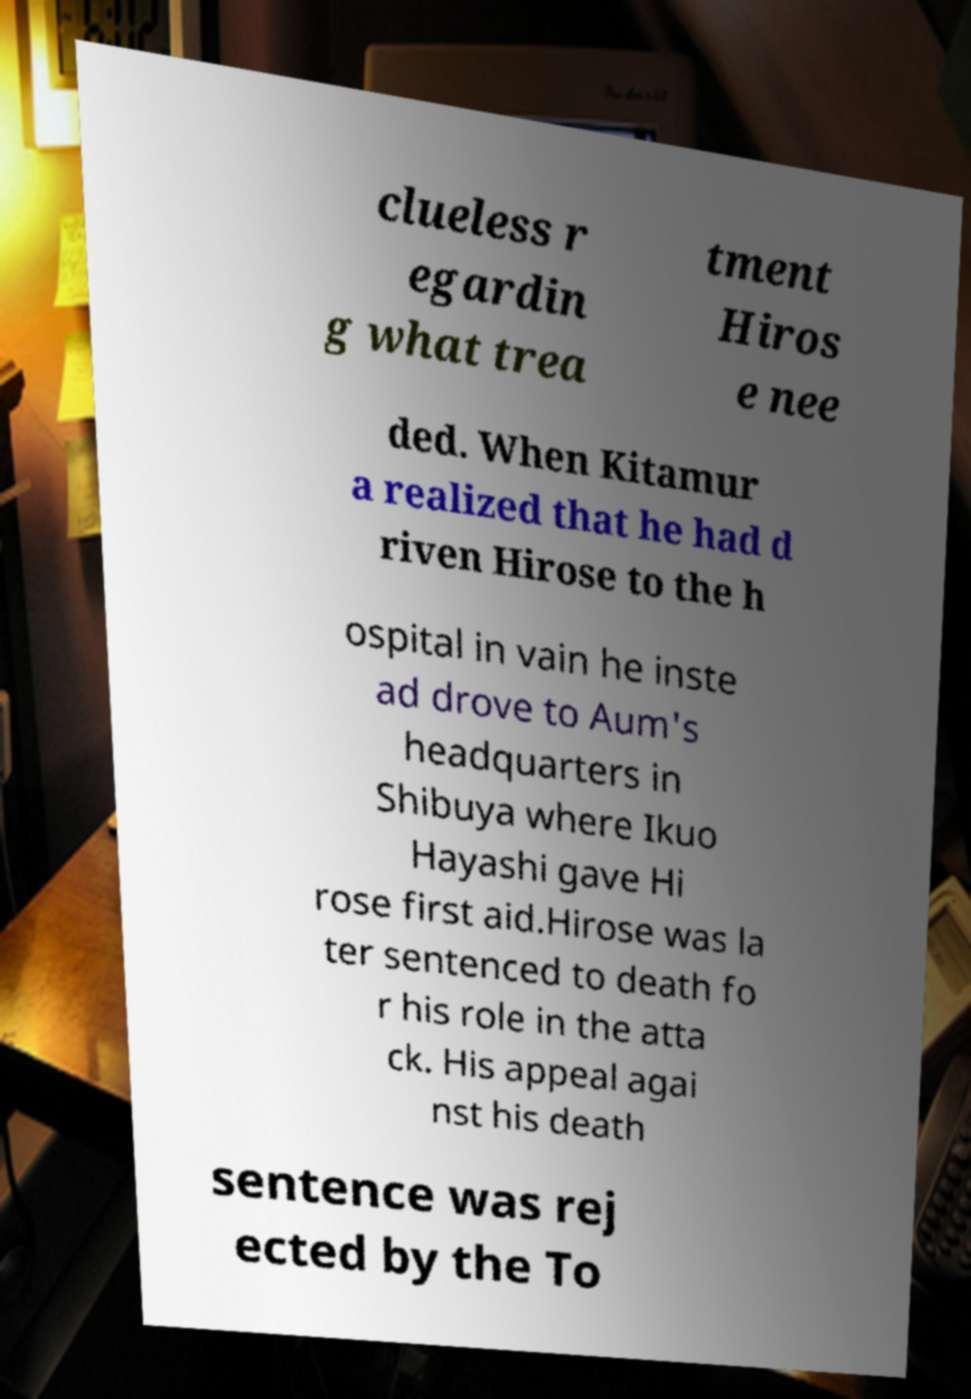I need the written content from this picture converted into text. Can you do that? clueless r egardin g what trea tment Hiros e nee ded. When Kitamur a realized that he had d riven Hirose to the h ospital in vain he inste ad drove to Aum's headquarters in Shibuya where Ikuo Hayashi gave Hi rose first aid.Hirose was la ter sentenced to death fo r his role in the atta ck. His appeal agai nst his death sentence was rej ected by the To 